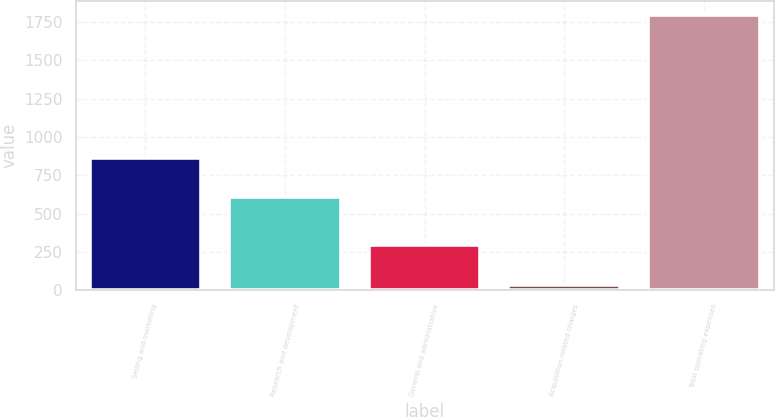Convert chart to OTSL. <chart><loc_0><loc_0><loc_500><loc_500><bar_chart><fcel>Selling and marketing<fcel>Research and development<fcel>General and administrative<fcel>Acquisition-related charges<fcel>Total operating expenses<nl><fcel>859.6<fcel>605.8<fcel>295<fcel>35.5<fcel>1795.9<nl></chart> 